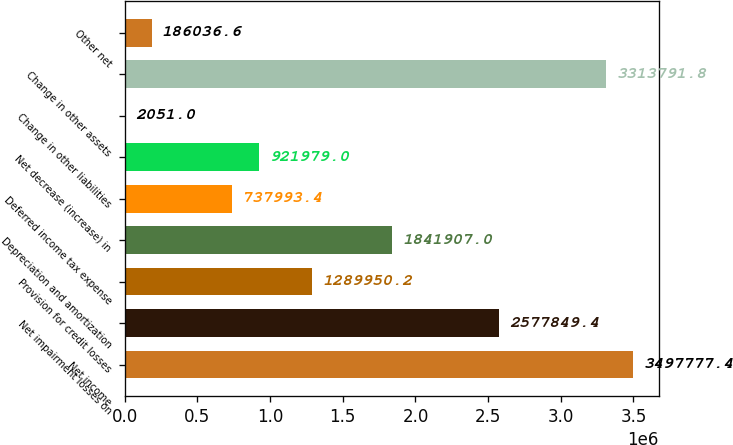<chart> <loc_0><loc_0><loc_500><loc_500><bar_chart><fcel>Net income<fcel>Net impairment losses on<fcel>Provision for credit losses<fcel>Depreciation and amortization<fcel>Deferred income tax expense<fcel>Net decrease (increase) in<fcel>Change in other liabilities<fcel>Change in other assets<fcel>Other net<nl><fcel>3.49778e+06<fcel>2.57785e+06<fcel>1.28995e+06<fcel>1.84191e+06<fcel>737993<fcel>921979<fcel>2051<fcel>3.31379e+06<fcel>186037<nl></chart> 